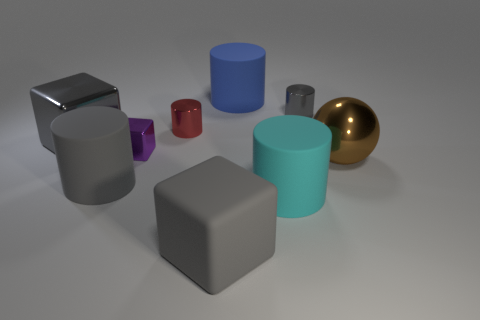What is the material of the large object that is behind the gray metal cube?
Keep it short and to the point. Rubber. Do the large gray block behind the large brown ball and the large cyan cylinder have the same material?
Your response must be concise. No. What shape is the cyan thing that is the same size as the brown sphere?
Your response must be concise. Cylinder. What number of large cylinders are the same color as the tiny metal cube?
Provide a short and direct response. 0. Is the number of cyan rubber cylinders in front of the small red metal thing less than the number of tiny red metal objects that are in front of the gray rubber block?
Your answer should be very brief. No. There is a tiny purple cube; are there any blue matte objects in front of it?
Your response must be concise. No. There is a rubber cylinder left of the big object that is behind the gray shiny cube; is there a big cube right of it?
Offer a very short reply. Yes. Is the shape of the large metallic thing that is behind the purple object the same as  the large cyan rubber thing?
Offer a very short reply. No. There is a tiny block that is the same material as the red thing; what color is it?
Keep it short and to the point. Purple. How many other things are made of the same material as the large cyan thing?
Provide a succinct answer. 3. 